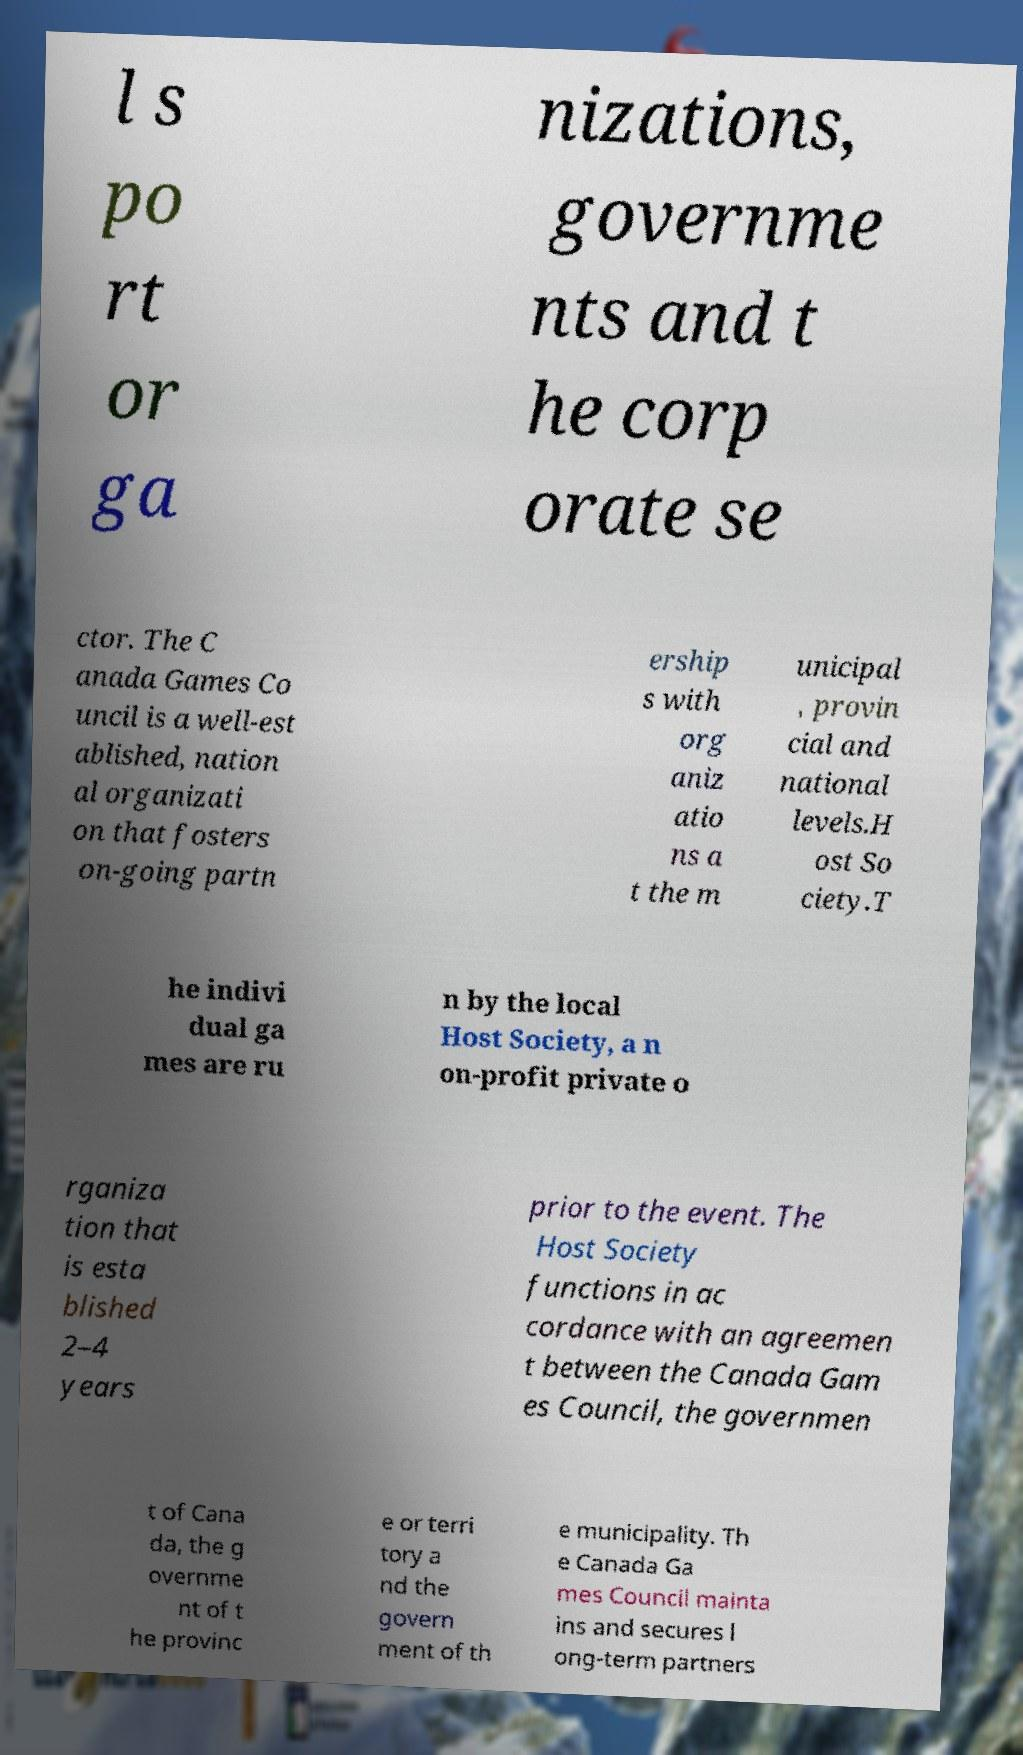Could you extract and type out the text from this image? l s po rt or ga nizations, governme nts and t he corp orate se ctor. The C anada Games Co uncil is a well-est ablished, nation al organizati on that fosters on-going partn ership s with org aniz atio ns a t the m unicipal , provin cial and national levels.H ost So ciety.T he indivi dual ga mes are ru n by the local Host Society, a n on-profit private o rganiza tion that is esta blished 2–4 years prior to the event. The Host Society functions in ac cordance with an agreemen t between the Canada Gam es Council, the governmen t of Cana da, the g overnme nt of t he provinc e or terri tory a nd the govern ment of th e municipality. Th e Canada Ga mes Council mainta ins and secures l ong-term partners 